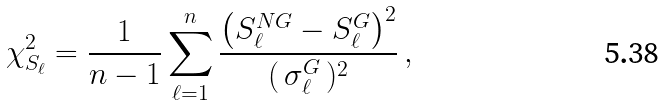Convert formula to latex. <formula><loc_0><loc_0><loc_500><loc_500>\chi ^ { 2 } _ { S _ { \ell } } = \frac { 1 } { n - 1 } \sum _ { \ell = 1 } ^ { n } \frac { \left ( { S _ { \ell } ^ { N G } } - { S _ { \ell } ^ { G } } \right ) ^ { 2 } } { ( \, { \sigma _ { \ell } ^ { G } } \, ) ^ { 2 } } \, ,</formula> 